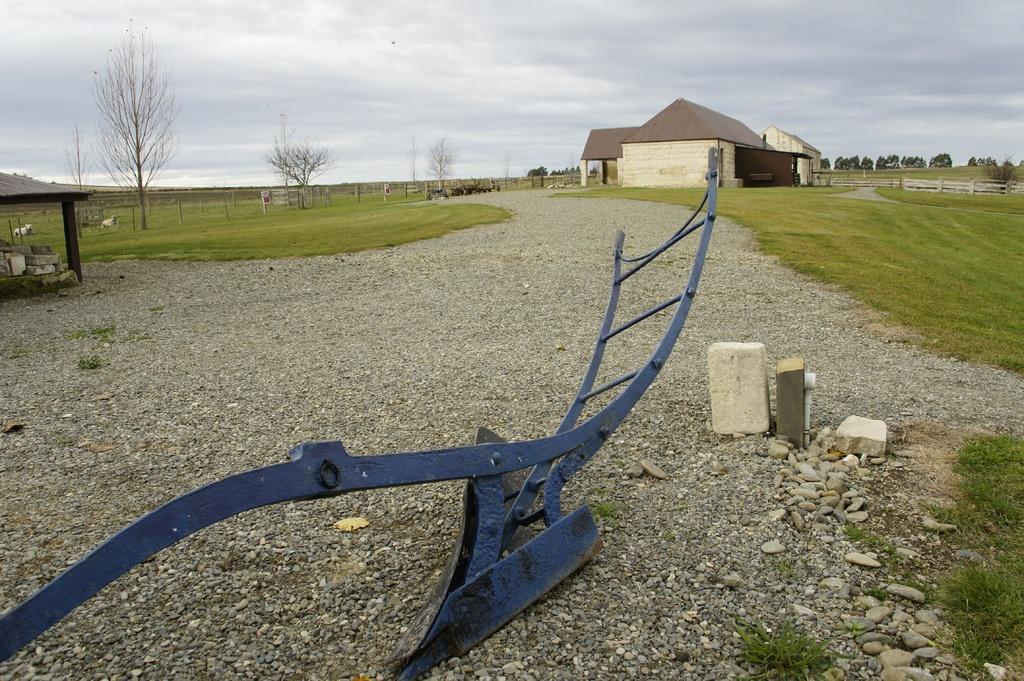In one or two sentences, can you explain what this image depicts? In this image we can see a ladder, some stones and grass. On the backside we can see a house with roof. we can also see pillars, grass, board, trees, fence and the sky which looks cloudy. 